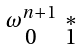Convert formula to latex. <formula><loc_0><loc_0><loc_500><loc_500>\begin{smallmatrix} \omega ^ { n + 1 } & * \\ 0 & 1 \end{smallmatrix}</formula> 